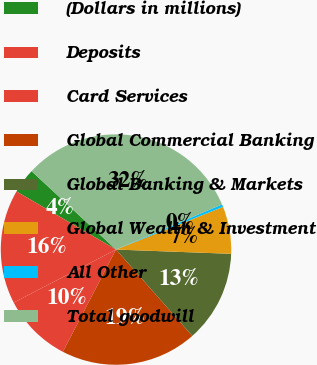Convert chart. <chart><loc_0><loc_0><loc_500><loc_500><pie_chart><fcel>(Dollars in millions)<fcel>Deposits<fcel>Card Services<fcel>Global Commercial Banking<fcel>Global Banking & Markets<fcel>Global Wealth & Investment<fcel>All Other<fcel>Total goodwill<nl><fcel>3.5%<fcel>16.02%<fcel>9.76%<fcel>19.15%<fcel>12.89%<fcel>6.63%<fcel>0.37%<fcel>31.68%<nl></chart> 